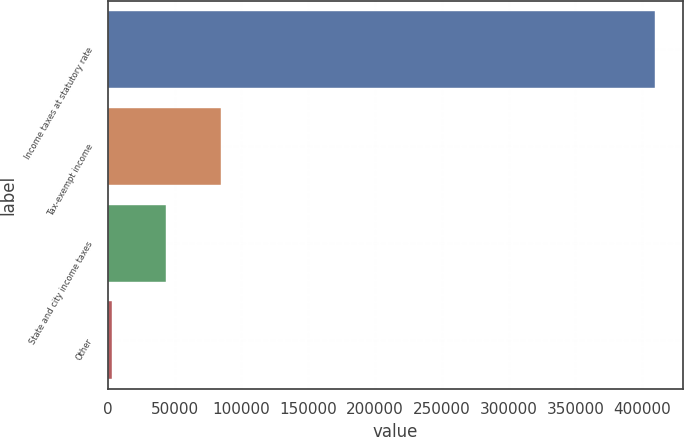<chart> <loc_0><loc_0><loc_500><loc_500><bar_chart><fcel>Income taxes at statutory rate<fcel>Tax-exempt income<fcel>State and city income taxes<fcel>Other<nl><fcel>409822<fcel>84435.6<fcel>43762.3<fcel>3089<nl></chart> 